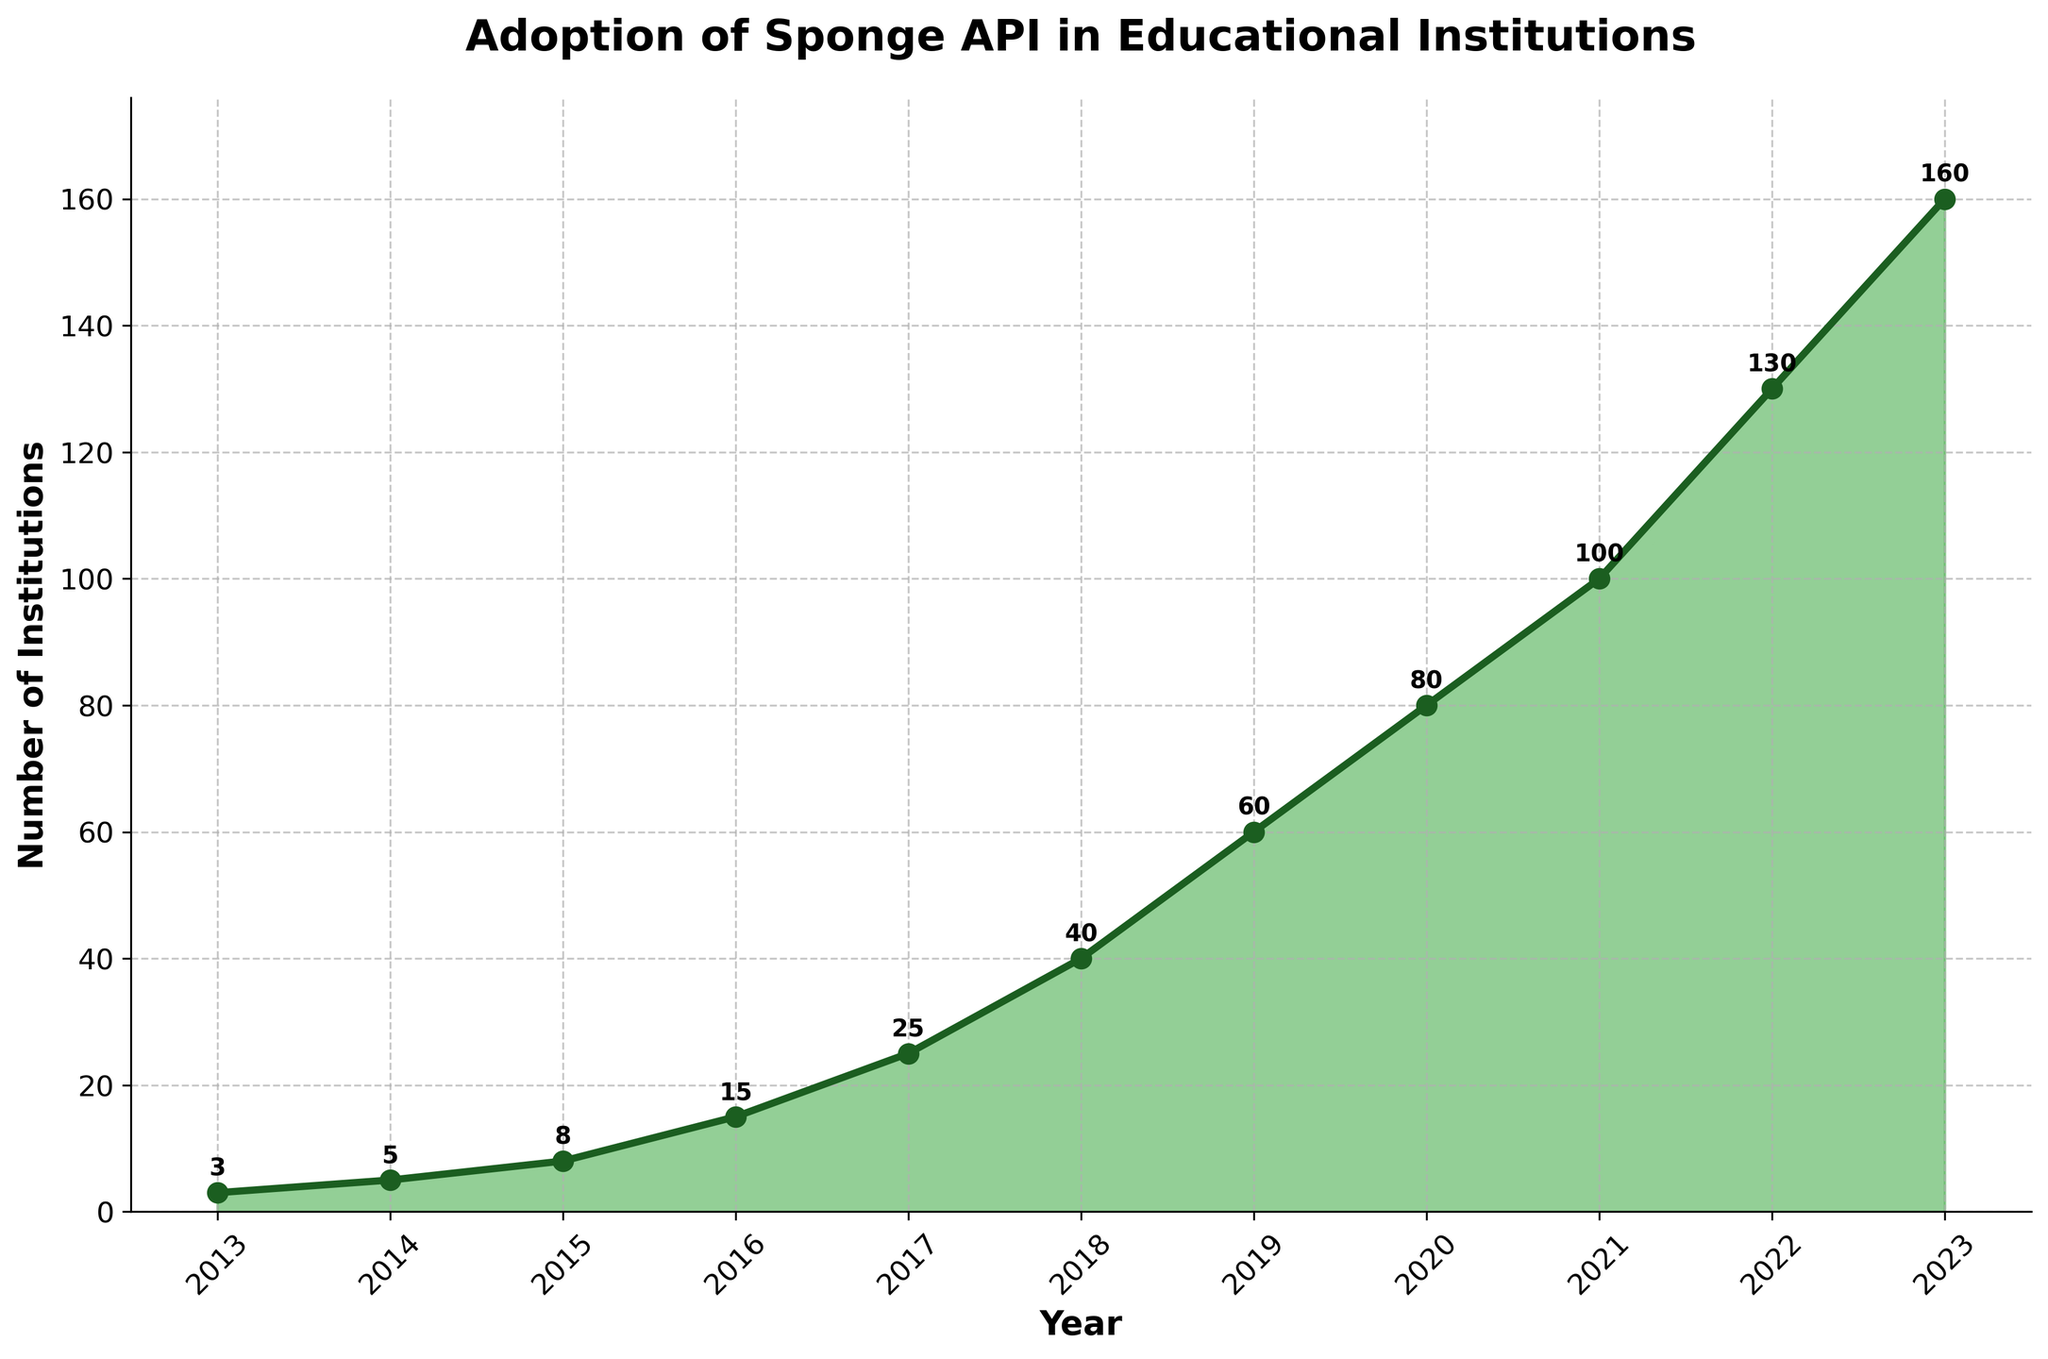What's the title of the chart? The title of the chart is prominently displayed at the top in bold text.
Answer: Adoption of Sponge API in Educational Institutions How many institutions adopted the Sponge API in 2017? Look at the data point corresponding to 2017 on the x-axis and note the y-axis value.
Answer: 25 In which year did the most significant increase in adoption occur? Compare the differences in the number of institutions for each consecutive year and identify the largest change. The largest jump is from 2018 to 2019 (from 40 to 60, a change of 20).
Answer: 2019 What is the average number of institutions adopting the Sponge API from 2013 to 2023? Sum the number of institutions from 2013 to 2023 and divide by the number of years (11). (3+5+8+15+25+40+60+80+100+130+160) / 11 = 56.36
Answer: 56.36 In which year did the number of adopting institutions reach 100? Look at the x-axis and find the year that corresponds to the 100 mark on the y-axis.
Answer: 2021 How does the number of institutions adopting the Sponge API in 2023 compare to that in 2019? Look at the y-axis values for 2023 and 2019 and compare them. 2023 has 160 institutions, and 2019 has 60.
Answer: 2023 has 100 more institutions than 2019 What was the rate of increase in adoption between 2020 and 2021? Subtract the number of institutions in 2020 from that in 2021 and divide by the number of institutions in 2020. ((100-80)/80)*100% = 25%
Answer: 25% How many data points are displayed on the chart? Count the number of distinct points plotted on the chart.
Answer: 11 Did the number of institutions increase every year from 2013 to 2023? Check the trend of the chart to see if each year's value is higher than the previous year's.
Answer: Yes What section of the chart shows the steepest slope and what does it indicate? Look for the segment with the steepest upward slope, indicating the fastest rate of adoption. This is between 2015 to 2019.
Answer: 2015 to 2019, indicating rapid adoption 